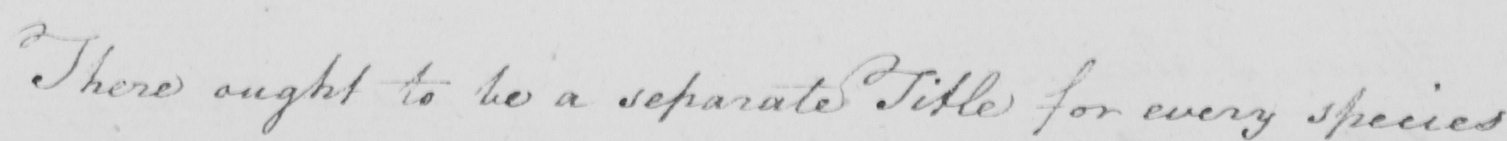What does this handwritten line say? There ought to be a separate Title for every species 